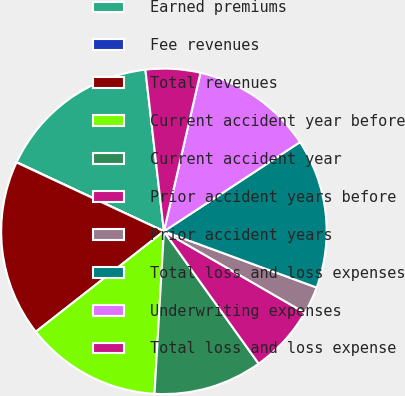Convert chart to OTSL. <chart><loc_0><loc_0><loc_500><loc_500><pie_chart><fcel>Earned premiums<fcel>Fee revenues<fcel>Total revenues<fcel>Current accident year before<fcel>Current accident year<fcel>Prior accident years before<fcel>Prior accident years<fcel>Total loss and loss expenses<fcel>Underwriting expenses<fcel>Total loss and loss expense<nl><fcel>16.2%<fcel>0.03%<fcel>17.54%<fcel>13.5%<fcel>10.81%<fcel>6.77%<fcel>2.73%<fcel>14.85%<fcel>12.16%<fcel>5.42%<nl></chart> 